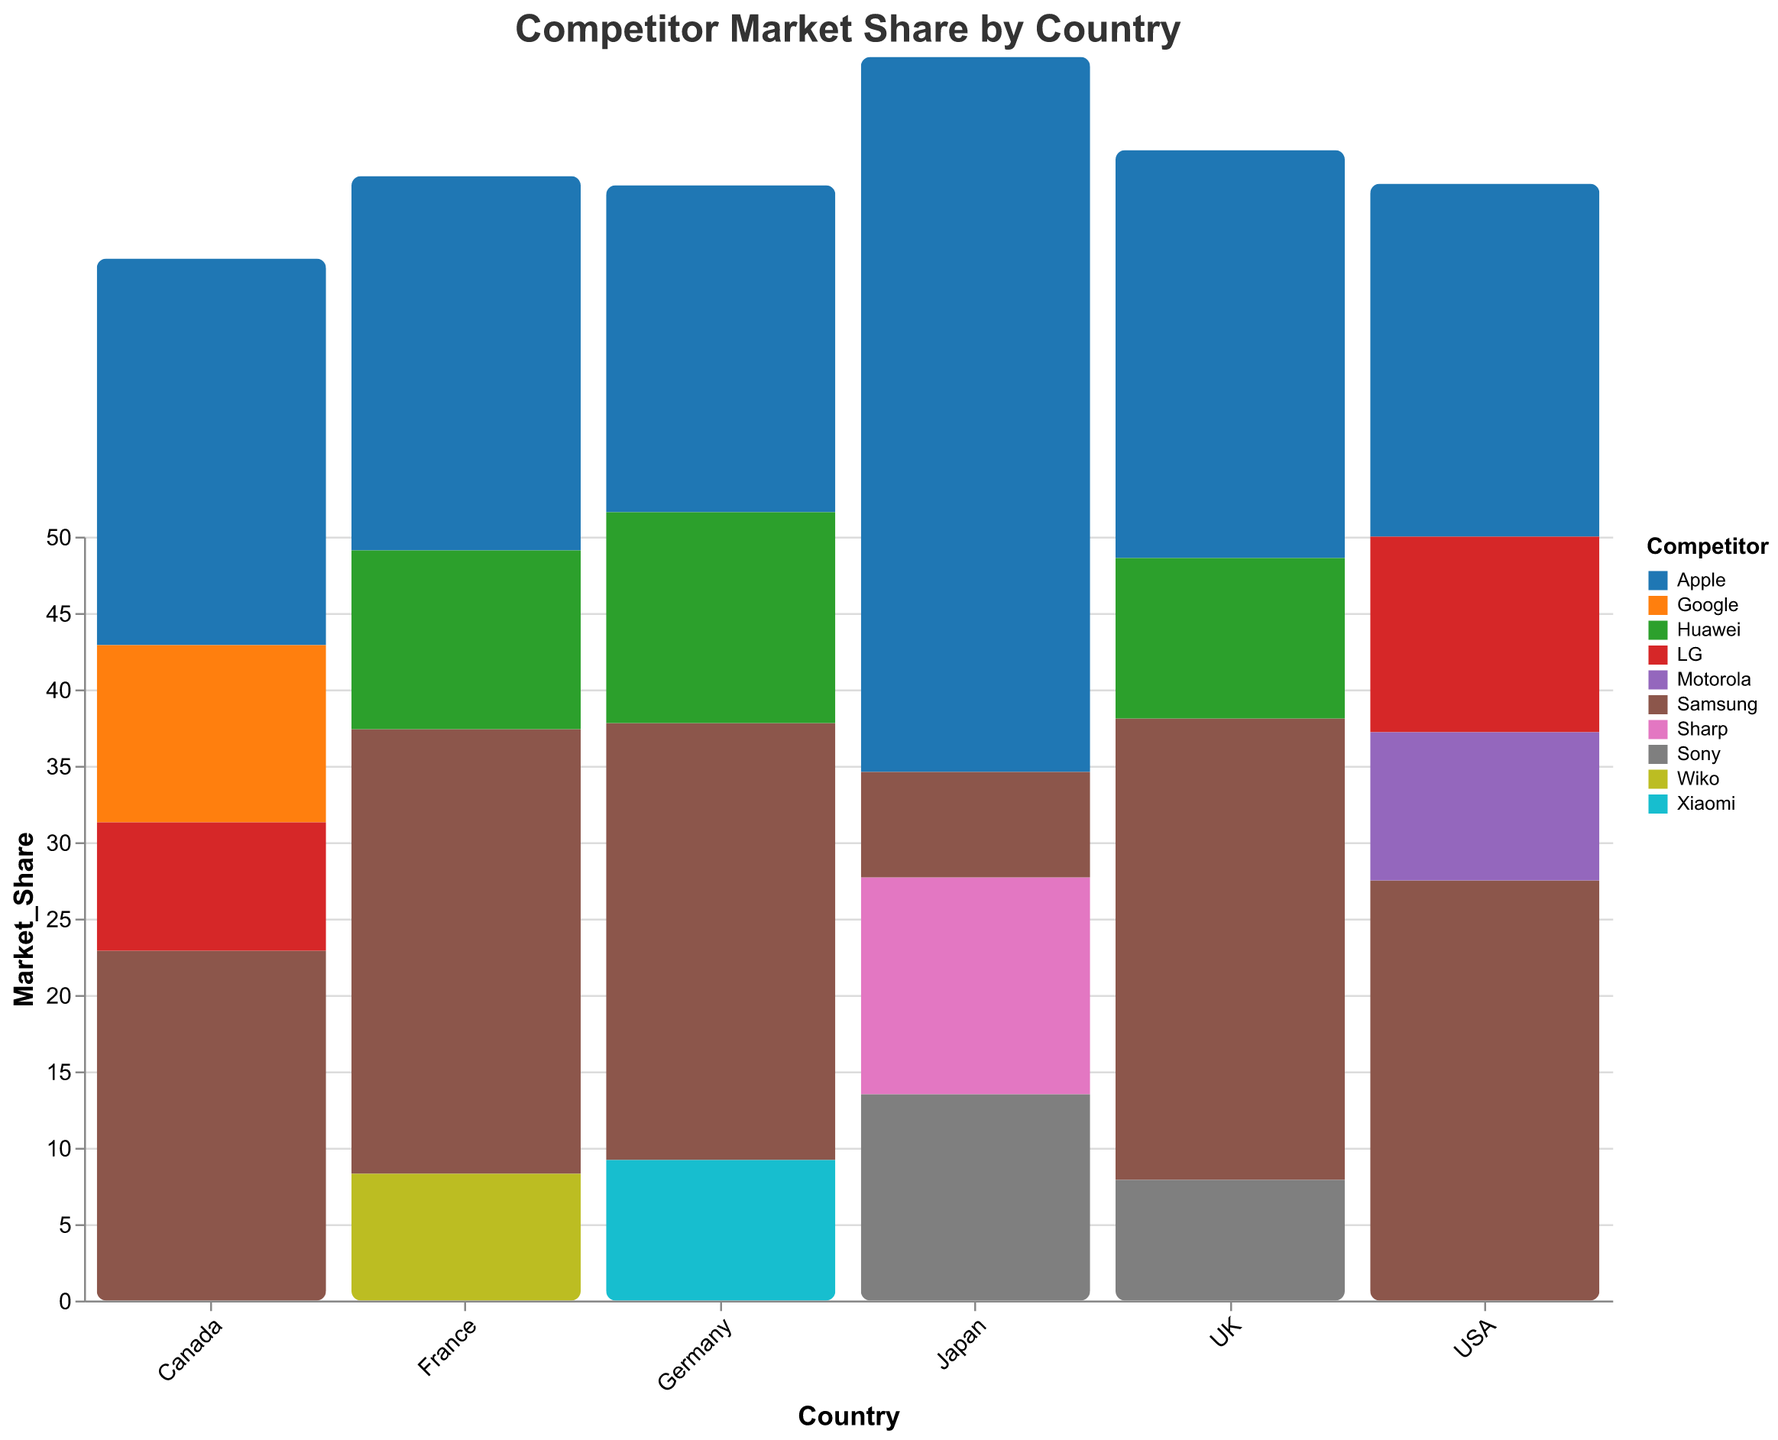Which country has the highest market share for Samsung? To determine which country has the highest market share for Samsung, look at the bars representing Samsung in each country's data. The country with the tallest bar for Samsung is the UK with 30.2%.
Answer: UK What is the market share difference between Apple and Samsung in the USA? To find the market share difference between Apple and Samsung in the USA, subtract the market share of Apple (23.1%) from that of Samsung (27.5%). The difference is 27.5 - 23.1 = 4.4%.
Answer: 4.4% Which competitor has the lowest market share in Japan? To identify the competitor with the lowest market share in Japan, look at the bars representing different competitors in Japan. Samsung has the lowest market share at 6.9%.
Answer: Samsung Between Canada and Germany, which country has a higher market share for LG? Compare the market share of LG in Canada and Germany. Canada has 8.4%, and Germany does not show LG in its list. Therefore, Canada has a higher market share for LG by default.
Answer: Canada What is the total market share of Huawei across all countries? To calculate the total market share of Huawei, add up Huawei's market share in the UK (10.5%), Germany (13.8%), and France (11.7%). The total is 10.5 + 13.8 + 11.7 = 36%.
Answer: 36% Which country has the highest total market share for all competitors combined? To find the country with the highest total market share, sum the market shares of all competitors in each country and compare. Japan has the highest total with Apple (46.8%), Sharp (14.2%), Sony (13.5%), and Samsung (6.9%) summing to 46.8 + 14.2 + 13.5 + 6.9 = 81.4%.
Answer: Japan Is Samsung's market share in France greater than LG's market share in the USA? Compare Samsung's market share in France (29.1%) to LG's market share in the USA (12.8%). Yes, 29.1% is greater than 12.8%.
Answer: Yes 